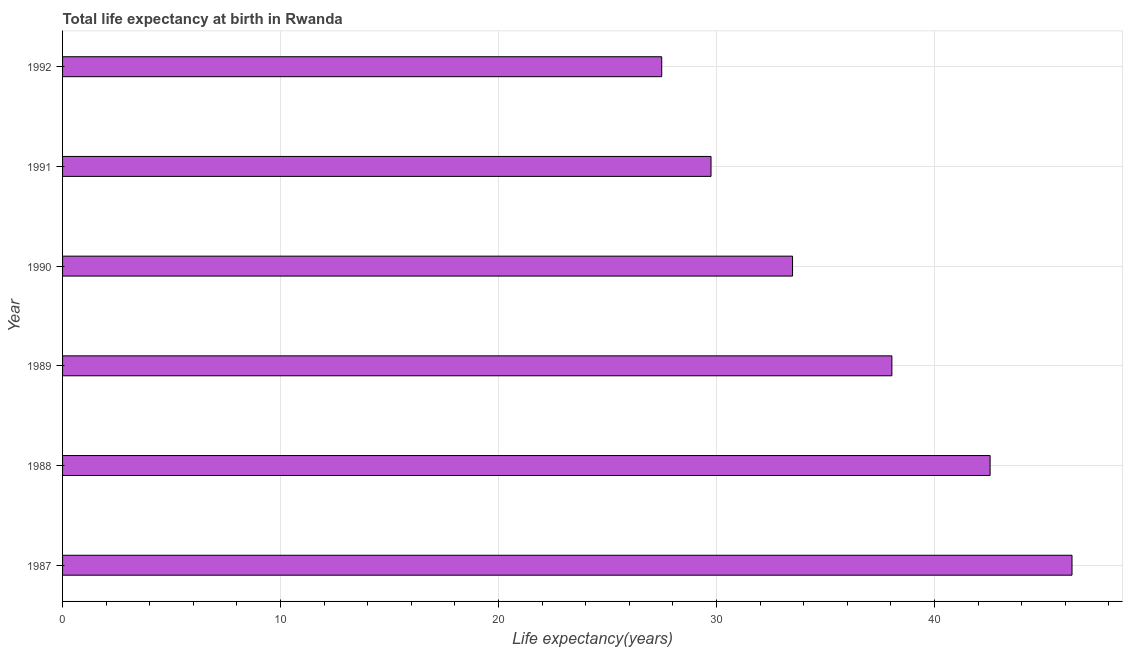Does the graph contain grids?
Make the answer very short. Yes. What is the title of the graph?
Provide a succinct answer. Total life expectancy at birth in Rwanda. What is the label or title of the X-axis?
Offer a terse response. Life expectancy(years). What is the label or title of the Y-axis?
Your answer should be compact. Year. What is the life expectancy at birth in 1991?
Your answer should be compact. 29.75. Across all years, what is the maximum life expectancy at birth?
Provide a short and direct response. 46.31. Across all years, what is the minimum life expectancy at birth?
Offer a very short reply. 27.48. In which year was the life expectancy at birth maximum?
Make the answer very short. 1987. What is the sum of the life expectancy at birth?
Provide a short and direct response. 217.61. What is the difference between the life expectancy at birth in 1988 and 1990?
Keep it short and to the point. 9.06. What is the average life expectancy at birth per year?
Ensure brevity in your answer.  36.27. What is the median life expectancy at birth?
Offer a terse response. 35.76. What is the ratio of the life expectancy at birth in 1990 to that in 1991?
Give a very brief answer. 1.13. Is the life expectancy at birth in 1987 less than that in 1989?
Provide a short and direct response. No. What is the difference between the highest and the second highest life expectancy at birth?
Offer a terse response. 3.76. What is the difference between the highest and the lowest life expectancy at birth?
Keep it short and to the point. 18.82. In how many years, is the life expectancy at birth greater than the average life expectancy at birth taken over all years?
Give a very brief answer. 3. How many bars are there?
Make the answer very short. 6. Are all the bars in the graph horizontal?
Provide a succinct answer. Yes. What is the difference between two consecutive major ticks on the X-axis?
Ensure brevity in your answer.  10. What is the Life expectancy(years) in 1987?
Give a very brief answer. 46.31. What is the Life expectancy(years) of 1988?
Provide a succinct answer. 42.55. What is the Life expectancy(years) of 1989?
Provide a short and direct response. 38.04. What is the Life expectancy(years) in 1990?
Offer a terse response. 33.49. What is the Life expectancy(years) in 1991?
Your response must be concise. 29.75. What is the Life expectancy(years) in 1992?
Ensure brevity in your answer.  27.48. What is the difference between the Life expectancy(years) in 1987 and 1988?
Your response must be concise. 3.76. What is the difference between the Life expectancy(years) in 1987 and 1989?
Your answer should be compact. 8.26. What is the difference between the Life expectancy(years) in 1987 and 1990?
Make the answer very short. 12.82. What is the difference between the Life expectancy(years) in 1987 and 1991?
Offer a very short reply. 16.56. What is the difference between the Life expectancy(years) in 1987 and 1992?
Provide a short and direct response. 18.82. What is the difference between the Life expectancy(years) in 1988 and 1989?
Give a very brief answer. 4.51. What is the difference between the Life expectancy(years) in 1988 and 1990?
Your answer should be compact. 9.06. What is the difference between the Life expectancy(years) in 1988 and 1991?
Make the answer very short. 12.8. What is the difference between the Life expectancy(years) in 1988 and 1992?
Your response must be concise. 15.06. What is the difference between the Life expectancy(years) in 1989 and 1990?
Your answer should be compact. 4.56. What is the difference between the Life expectancy(years) in 1989 and 1991?
Your response must be concise. 8.3. What is the difference between the Life expectancy(years) in 1989 and 1992?
Provide a short and direct response. 10.56. What is the difference between the Life expectancy(years) in 1990 and 1991?
Your answer should be compact. 3.74. What is the difference between the Life expectancy(years) in 1990 and 1992?
Offer a terse response. 6. What is the difference between the Life expectancy(years) in 1991 and 1992?
Provide a short and direct response. 2.26. What is the ratio of the Life expectancy(years) in 1987 to that in 1988?
Your answer should be compact. 1.09. What is the ratio of the Life expectancy(years) in 1987 to that in 1989?
Your answer should be very brief. 1.22. What is the ratio of the Life expectancy(years) in 1987 to that in 1990?
Make the answer very short. 1.38. What is the ratio of the Life expectancy(years) in 1987 to that in 1991?
Offer a very short reply. 1.56. What is the ratio of the Life expectancy(years) in 1987 to that in 1992?
Offer a very short reply. 1.69. What is the ratio of the Life expectancy(years) in 1988 to that in 1989?
Ensure brevity in your answer.  1.12. What is the ratio of the Life expectancy(years) in 1988 to that in 1990?
Your response must be concise. 1.27. What is the ratio of the Life expectancy(years) in 1988 to that in 1991?
Your answer should be very brief. 1.43. What is the ratio of the Life expectancy(years) in 1988 to that in 1992?
Your response must be concise. 1.55. What is the ratio of the Life expectancy(years) in 1989 to that in 1990?
Your answer should be compact. 1.14. What is the ratio of the Life expectancy(years) in 1989 to that in 1991?
Ensure brevity in your answer.  1.28. What is the ratio of the Life expectancy(years) in 1989 to that in 1992?
Ensure brevity in your answer.  1.38. What is the ratio of the Life expectancy(years) in 1990 to that in 1991?
Your answer should be compact. 1.13. What is the ratio of the Life expectancy(years) in 1990 to that in 1992?
Your response must be concise. 1.22. What is the ratio of the Life expectancy(years) in 1991 to that in 1992?
Your answer should be compact. 1.08. 